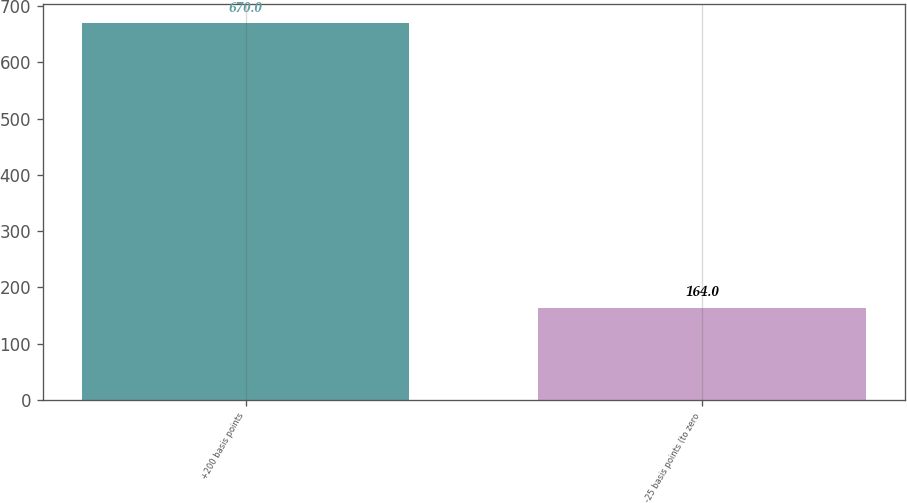Convert chart to OTSL. <chart><loc_0><loc_0><loc_500><loc_500><bar_chart><fcel>+200 basis points<fcel>-25 basis points (to zero<nl><fcel>670<fcel>164<nl></chart> 